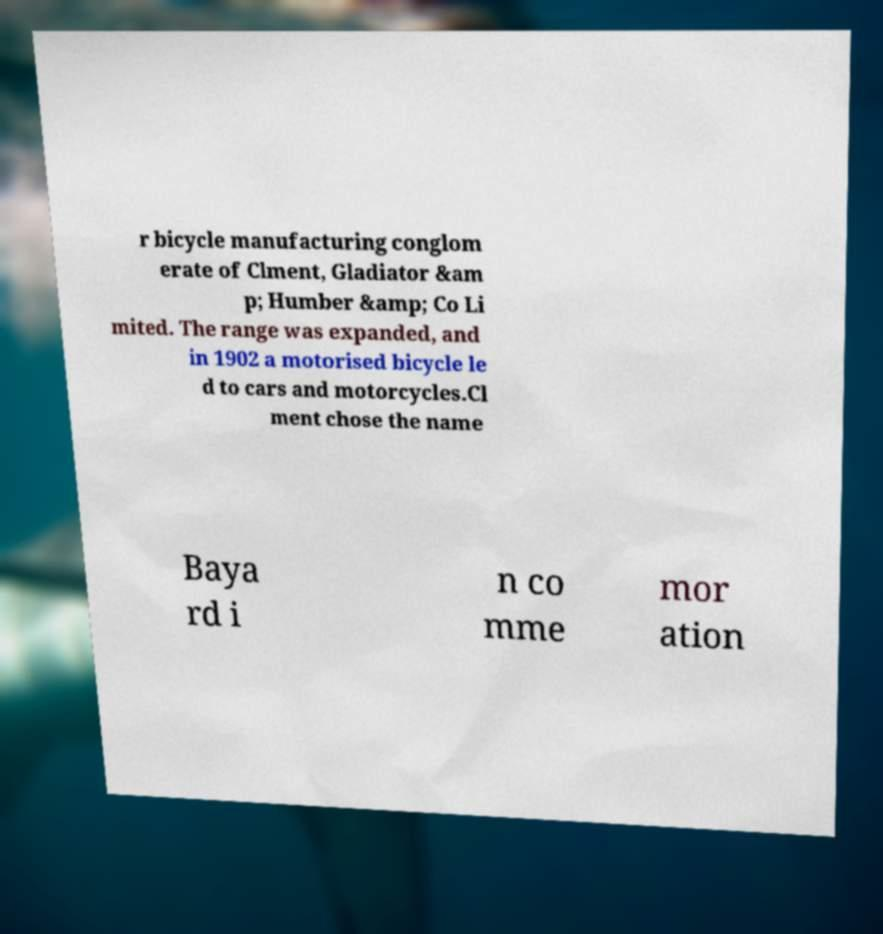For documentation purposes, I need the text within this image transcribed. Could you provide that? r bicycle manufacturing conglom erate of Clment, Gladiator &am p; Humber &amp; Co Li mited. The range was expanded, and in 1902 a motorised bicycle le d to cars and motorcycles.Cl ment chose the name Baya rd i n co mme mor ation 